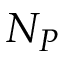Convert formula to latex. <formula><loc_0><loc_0><loc_500><loc_500>N _ { P }</formula> 